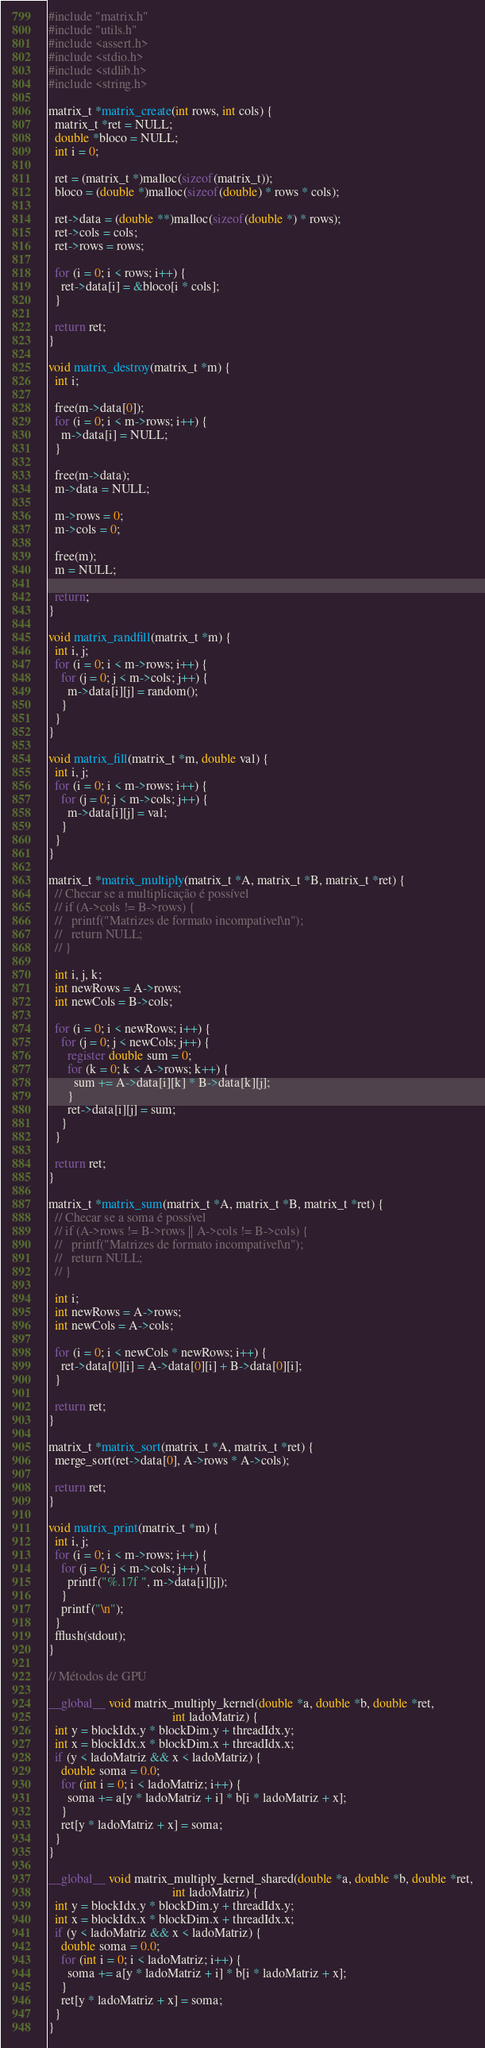Convert code to text. <code><loc_0><loc_0><loc_500><loc_500><_Cuda_>#include "matrix.h"
#include "utils.h"
#include <assert.h>
#include <stdio.h>
#include <stdlib.h>
#include <string.h>

matrix_t *matrix_create(int rows, int cols) {
  matrix_t *ret = NULL;
  double *bloco = NULL;
  int i = 0;

  ret = (matrix_t *)malloc(sizeof(matrix_t));
  bloco = (double *)malloc(sizeof(double) * rows * cols);

  ret->data = (double **)malloc(sizeof(double *) * rows);
  ret->cols = cols;
  ret->rows = rows;

  for (i = 0; i < rows; i++) {
    ret->data[i] = &bloco[i * cols];
  }

  return ret;
}

void matrix_destroy(matrix_t *m) {
  int i;

  free(m->data[0]);
  for (i = 0; i < m->rows; i++) {
    m->data[i] = NULL;
  }

  free(m->data);
  m->data = NULL;

  m->rows = 0;
  m->cols = 0;

  free(m);
  m = NULL;

  return;
}

void matrix_randfill(matrix_t *m) {
  int i, j;
  for (i = 0; i < m->rows; i++) {
    for (j = 0; j < m->cols; j++) {
      m->data[i][j] = random();
    }
  }
}

void matrix_fill(matrix_t *m, double val) {
  int i, j;
  for (i = 0; i < m->rows; i++) {
    for (j = 0; j < m->cols; j++) {
      m->data[i][j] = val;
    }
  }
}

matrix_t *matrix_multiply(matrix_t *A, matrix_t *B, matrix_t *ret) {
  // Checar se a multiplicação é possível
  // if (A->cols != B->rows) {
  //   printf("Matrizes de formato incompativel\n");
  //   return NULL;
  // }

  int i, j, k;
  int newRows = A->rows;
  int newCols = B->cols;

  for (i = 0; i < newRows; i++) {
    for (j = 0; j < newCols; j++) {
      register double sum = 0;
      for (k = 0; k < A->rows; k++) {
        sum += A->data[i][k] * B->data[k][j];
      }
      ret->data[i][j] = sum;
    }
  }

  return ret;
}

matrix_t *matrix_sum(matrix_t *A, matrix_t *B, matrix_t *ret) {
  // Checar se a soma é possível
  // if (A->rows != B->rows || A->cols != B->cols) {
  //   printf("Matrizes de formato incompativel\n");
  //   return NULL;
  // }

  int i;
  int newRows = A->rows;
  int newCols = A->cols;

  for (i = 0; i < newCols * newRows; i++) {
    ret->data[0][i] = A->data[0][i] + B->data[0][i];
  }

  return ret;
}

matrix_t *matrix_sort(matrix_t *A, matrix_t *ret) {
  merge_sort(ret->data[0], A->rows * A->cols);

  return ret;
}

void matrix_print(matrix_t *m) {
  int i, j;
  for (i = 0; i < m->rows; i++) {
    for (j = 0; j < m->cols; j++) {
      printf("%.17f ", m->data[i][j]);
    }
    printf("\n");
  }
  fflush(stdout);
}

// Métodos de GPU

__global__ void matrix_multiply_kernel(double *a, double *b, double *ret,
                                       int ladoMatriz) {
  int y = blockIdx.y * blockDim.y + threadIdx.y;
  int x = blockIdx.x * blockDim.x + threadIdx.x;
  if (y < ladoMatriz && x < ladoMatriz) {
    double soma = 0.0;
    for (int i = 0; i < ladoMatriz; i++) {
      soma += a[y * ladoMatriz + i] * b[i * ladoMatriz + x];
    }
    ret[y * ladoMatriz + x] = soma;
  }
}

__global__ void matrix_multiply_kernel_shared(double *a, double *b, double *ret,
                                       int ladoMatriz) {
  int y = blockIdx.y * blockDim.y + threadIdx.y;
  int x = blockIdx.x * blockDim.x + threadIdx.x;
  if (y < ladoMatriz && x < ladoMatriz) {
    double soma = 0.0;
    for (int i = 0; i < ladoMatriz; i++) {
      soma += a[y * ladoMatriz + i] * b[i * ladoMatriz + x];
    }
    ret[y * ladoMatriz + x] = soma;
  }
}
</code> 